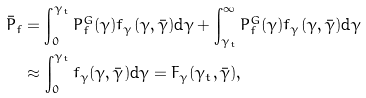Convert formula to latex. <formula><loc_0><loc_0><loc_500><loc_500>\bar { P } _ { f } & = \int _ { 0 } ^ { \gamma _ { t } } P _ { f } ^ { G } ( \gamma ) f _ { \gamma } ( \gamma , \bar { \gamma } ) \text {d} \gamma + \int _ { \gamma _ { t } } ^ { \infty } P _ { f } ^ { G } ( \gamma ) f _ { \gamma } ( \gamma , \bar { \gamma } ) \text {d} \gamma \\ & \approx \int _ { 0 } ^ { \gamma _ { t } } f _ { \gamma } ( \gamma , \bar { \gamma } ) \text {d} \gamma = F _ { \gamma } ( \gamma _ { t } , \bar { \gamma } ) ,</formula> 